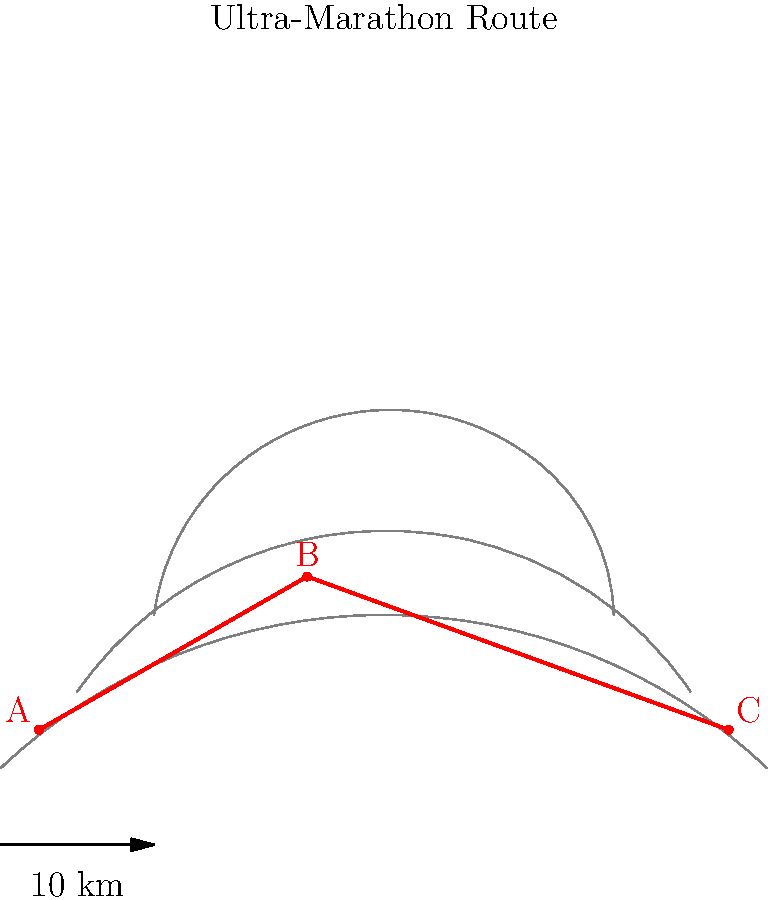A multi-stage ultra-marathon route is shown on a topographic map. The route consists of three stages: A to B, B to C, and C back to A. Given that the map scale is 1:100,000 and the straight-line distances between points are:
AB = 4.2 cm
BC = 5.5 cm
CA = 9.0 cm
Calculate the total distance of the ultra-marathon route in kilometers, accounting for an additional 15% distance due to elevation changes and terrain difficulty. To solve this problem, we'll follow these steps:

1. Convert map distances to real distances:
   At 1:100,000 scale, 1 cm on the map represents 1 km in real distance.
   AB: 4.2 cm × 1 km/cm = 4.2 km
   BC: 5.5 cm × 1 km/cm = 5.5 km
   CA: 9.0 cm × 1 km/cm = 9.0 km

2. Calculate the total straight-line distance:
   Total = AB + BC + CA
   Total = 4.2 km + 5.5 km + 9.0 km = 18.7 km

3. Account for elevation changes and terrain difficulty:
   Add 15% to the total distance
   Additional distance = 18.7 km × 0.15 = 2.805 km

4. Calculate the final total distance:
   Final total = Straight-line total + Additional distance
   Final total = 18.7 km + 2.805 km = 21.505 km

5. Round to a reasonable precision for ultra-marathon distances:
   Rounded total = 21.5 km
Answer: 21.5 km 